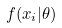Convert formula to latex. <formula><loc_0><loc_0><loc_500><loc_500>f ( x _ { i } | \theta )</formula> 